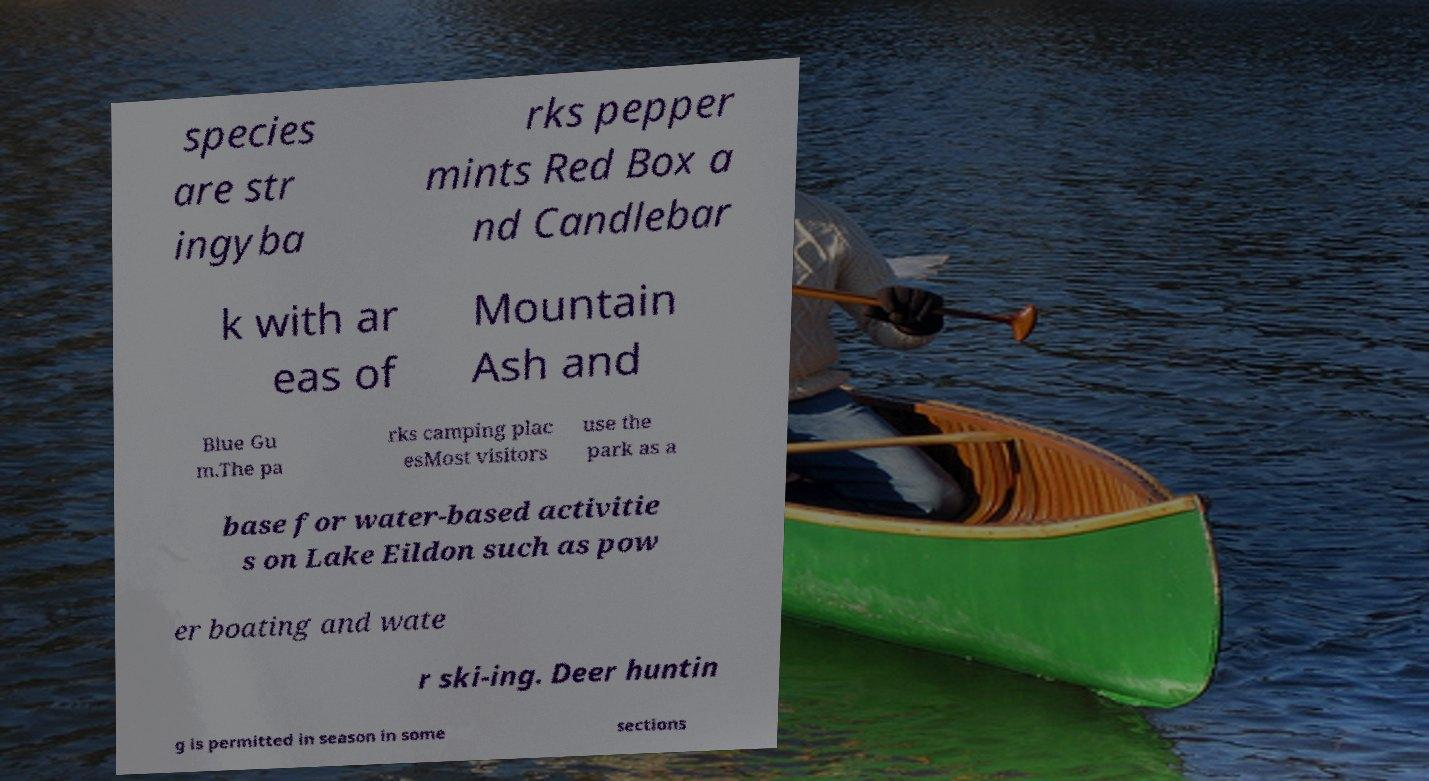For documentation purposes, I need the text within this image transcribed. Could you provide that? species are str ingyba rks pepper mints Red Box a nd Candlebar k with ar eas of Mountain Ash and Blue Gu m.The pa rks camping plac esMost visitors use the park as a base for water-based activitie s on Lake Eildon such as pow er boating and wate r ski-ing. Deer huntin g is permitted in season in some sections 